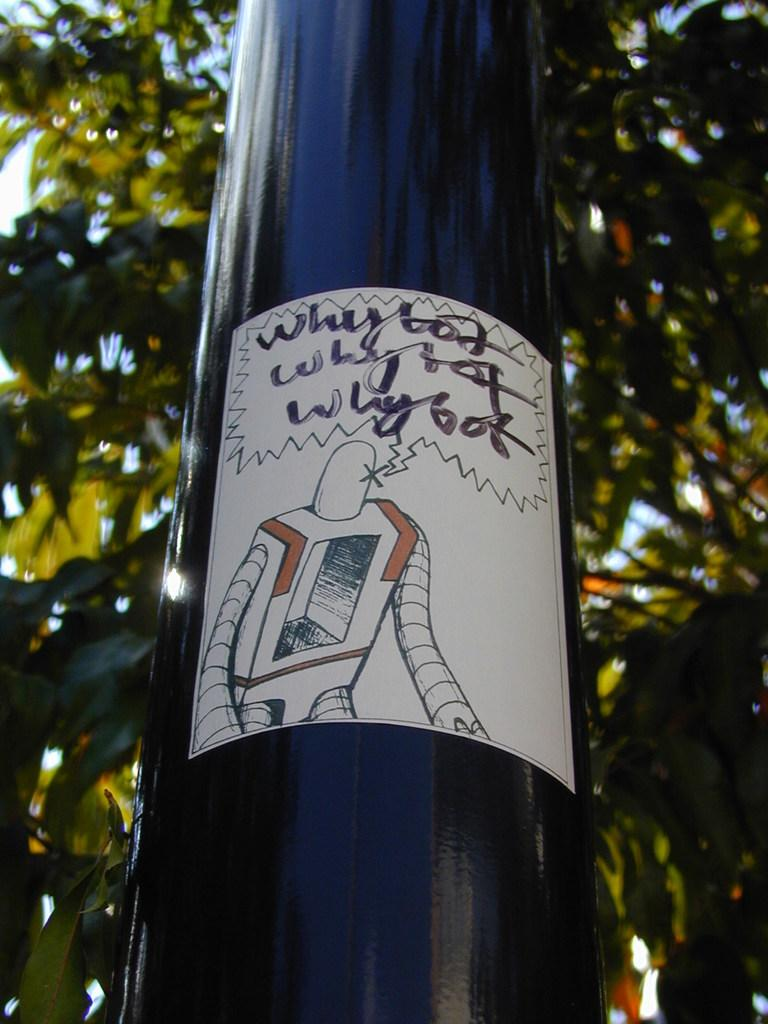<image>
Create a compact narrative representing the image presented. A pole with a drawing of a robot on it that says why bot. 